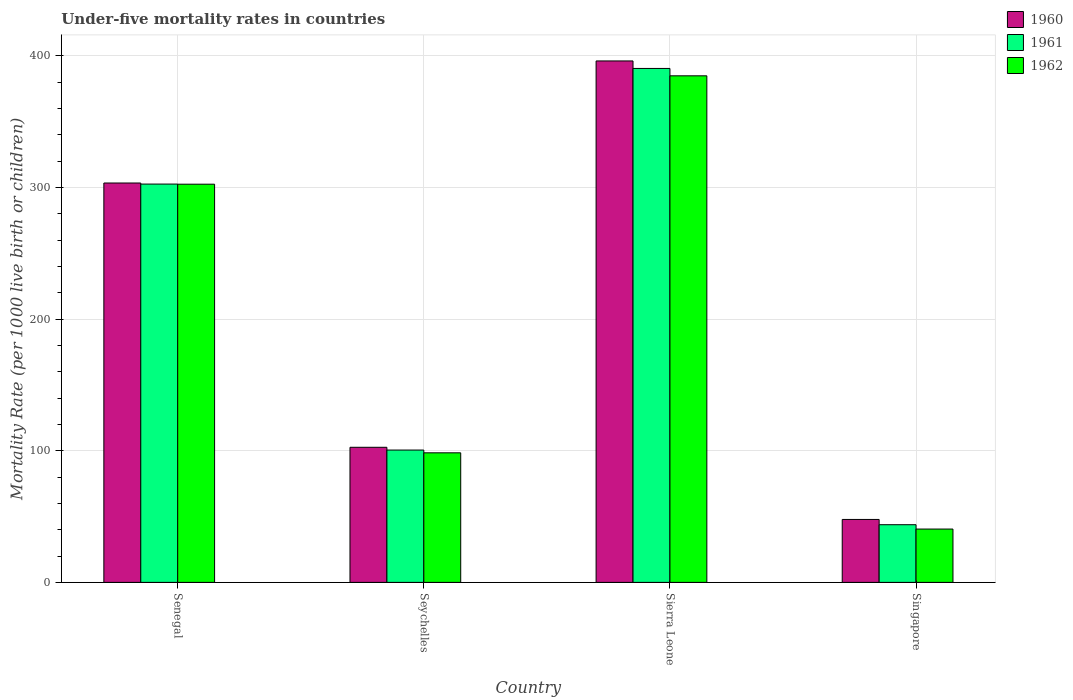How many different coloured bars are there?
Offer a very short reply. 3. How many groups of bars are there?
Provide a short and direct response. 4. Are the number of bars per tick equal to the number of legend labels?
Your answer should be very brief. Yes. Are the number of bars on each tick of the X-axis equal?
Provide a short and direct response. Yes. How many bars are there on the 4th tick from the left?
Your response must be concise. 3. What is the label of the 3rd group of bars from the left?
Keep it short and to the point. Sierra Leone. In how many cases, is the number of bars for a given country not equal to the number of legend labels?
Offer a very short reply. 0. What is the under-five mortality rate in 1960 in Sierra Leone?
Make the answer very short. 396. Across all countries, what is the maximum under-five mortality rate in 1961?
Your response must be concise. 390.3. Across all countries, what is the minimum under-five mortality rate in 1960?
Keep it short and to the point. 47.8. In which country was the under-five mortality rate in 1962 maximum?
Your answer should be compact. Sierra Leone. In which country was the under-five mortality rate in 1960 minimum?
Your response must be concise. Singapore. What is the total under-five mortality rate in 1961 in the graph?
Give a very brief answer. 837.1. What is the difference between the under-five mortality rate in 1962 in Sierra Leone and that in Singapore?
Keep it short and to the point. 344.2. What is the difference between the under-five mortality rate in 1960 in Sierra Leone and the under-five mortality rate in 1961 in Senegal?
Provide a succinct answer. 93.5. What is the average under-five mortality rate in 1961 per country?
Keep it short and to the point. 209.27. What is the difference between the under-five mortality rate of/in 1961 and under-five mortality rate of/in 1962 in Seychelles?
Provide a short and direct response. 2.1. In how many countries, is the under-five mortality rate in 1960 greater than 80?
Offer a very short reply. 3. What is the ratio of the under-five mortality rate in 1962 in Senegal to that in Singapore?
Ensure brevity in your answer.  7.47. What is the difference between the highest and the second highest under-five mortality rate in 1961?
Your answer should be compact. 202. What is the difference between the highest and the lowest under-five mortality rate in 1960?
Provide a short and direct response. 348.2. In how many countries, is the under-five mortality rate in 1960 greater than the average under-five mortality rate in 1960 taken over all countries?
Offer a very short reply. 2. What does the 1st bar from the left in Sierra Leone represents?
Offer a very short reply. 1960. How many bars are there?
Your answer should be very brief. 12. Are all the bars in the graph horizontal?
Ensure brevity in your answer.  No. How many countries are there in the graph?
Make the answer very short. 4. What is the difference between two consecutive major ticks on the Y-axis?
Keep it short and to the point. 100. Does the graph contain any zero values?
Your answer should be compact. No. Does the graph contain grids?
Make the answer very short. Yes. Where does the legend appear in the graph?
Your answer should be compact. Top right. What is the title of the graph?
Offer a very short reply. Under-five mortality rates in countries. What is the label or title of the X-axis?
Keep it short and to the point. Country. What is the label or title of the Y-axis?
Provide a short and direct response. Mortality Rate (per 1000 live birth or children). What is the Mortality Rate (per 1000 live birth or children) in 1960 in Senegal?
Make the answer very short. 303.3. What is the Mortality Rate (per 1000 live birth or children) of 1961 in Senegal?
Provide a succinct answer. 302.5. What is the Mortality Rate (per 1000 live birth or children) of 1962 in Senegal?
Your answer should be compact. 302.4. What is the Mortality Rate (per 1000 live birth or children) of 1960 in Seychelles?
Ensure brevity in your answer.  102.6. What is the Mortality Rate (per 1000 live birth or children) in 1961 in Seychelles?
Your answer should be very brief. 100.5. What is the Mortality Rate (per 1000 live birth or children) in 1962 in Seychelles?
Your answer should be compact. 98.4. What is the Mortality Rate (per 1000 live birth or children) in 1960 in Sierra Leone?
Keep it short and to the point. 396. What is the Mortality Rate (per 1000 live birth or children) in 1961 in Sierra Leone?
Make the answer very short. 390.3. What is the Mortality Rate (per 1000 live birth or children) in 1962 in Sierra Leone?
Your answer should be very brief. 384.7. What is the Mortality Rate (per 1000 live birth or children) in 1960 in Singapore?
Ensure brevity in your answer.  47.8. What is the Mortality Rate (per 1000 live birth or children) in 1961 in Singapore?
Ensure brevity in your answer.  43.8. What is the Mortality Rate (per 1000 live birth or children) in 1962 in Singapore?
Your answer should be very brief. 40.5. Across all countries, what is the maximum Mortality Rate (per 1000 live birth or children) in 1960?
Offer a terse response. 396. Across all countries, what is the maximum Mortality Rate (per 1000 live birth or children) in 1961?
Your answer should be compact. 390.3. Across all countries, what is the maximum Mortality Rate (per 1000 live birth or children) in 1962?
Your answer should be compact. 384.7. Across all countries, what is the minimum Mortality Rate (per 1000 live birth or children) of 1960?
Provide a succinct answer. 47.8. Across all countries, what is the minimum Mortality Rate (per 1000 live birth or children) in 1961?
Provide a short and direct response. 43.8. Across all countries, what is the minimum Mortality Rate (per 1000 live birth or children) of 1962?
Give a very brief answer. 40.5. What is the total Mortality Rate (per 1000 live birth or children) of 1960 in the graph?
Give a very brief answer. 849.7. What is the total Mortality Rate (per 1000 live birth or children) of 1961 in the graph?
Provide a short and direct response. 837.1. What is the total Mortality Rate (per 1000 live birth or children) of 1962 in the graph?
Give a very brief answer. 826. What is the difference between the Mortality Rate (per 1000 live birth or children) of 1960 in Senegal and that in Seychelles?
Your response must be concise. 200.7. What is the difference between the Mortality Rate (per 1000 live birth or children) in 1961 in Senegal and that in Seychelles?
Keep it short and to the point. 202. What is the difference between the Mortality Rate (per 1000 live birth or children) of 1962 in Senegal and that in Seychelles?
Offer a terse response. 204. What is the difference between the Mortality Rate (per 1000 live birth or children) in 1960 in Senegal and that in Sierra Leone?
Provide a succinct answer. -92.7. What is the difference between the Mortality Rate (per 1000 live birth or children) in 1961 in Senegal and that in Sierra Leone?
Offer a very short reply. -87.8. What is the difference between the Mortality Rate (per 1000 live birth or children) in 1962 in Senegal and that in Sierra Leone?
Your answer should be very brief. -82.3. What is the difference between the Mortality Rate (per 1000 live birth or children) of 1960 in Senegal and that in Singapore?
Provide a short and direct response. 255.5. What is the difference between the Mortality Rate (per 1000 live birth or children) of 1961 in Senegal and that in Singapore?
Keep it short and to the point. 258.7. What is the difference between the Mortality Rate (per 1000 live birth or children) of 1962 in Senegal and that in Singapore?
Your response must be concise. 261.9. What is the difference between the Mortality Rate (per 1000 live birth or children) in 1960 in Seychelles and that in Sierra Leone?
Provide a short and direct response. -293.4. What is the difference between the Mortality Rate (per 1000 live birth or children) in 1961 in Seychelles and that in Sierra Leone?
Your answer should be very brief. -289.8. What is the difference between the Mortality Rate (per 1000 live birth or children) of 1962 in Seychelles and that in Sierra Leone?
Ensure brevity in your answer.  -286.3. What is the difference between the Mortality Rate (per 1000 live birth or children) of 1960 in Seychelles and that in Singapore?
Provide a short and direct response. 54.8. What is the difference between the Mortality Rate (per 1000 live birth or children) in 1961 in Seychelles and that in Singapore?
Provide a succinct answer. 56.7. What is the difference between the Mortality Rate (per 1000 live birth or children) in 1962 in Seychelles and that in Singapore?
Keep it short and to the point. 57.9. What is the difference between the Mortality Rate (per 1000 live birth or children) in 1960 in Sierra Leone and that in Singapore?
Your answer should be very brief. 348.2. What is the difference between the Mortality Rate (per 1000 live birth or children) of 1961 in Sierra Leone and that in Singapore?
Give a very brief answer. 346.5. What is the difference between the Mortality Rate (per 1000 live birth or children) of 1962 in Sierra Leone and that in Singapore?
Give a very brief answer. 344.2. What is the difference between the Mortality Rate (per 1000 live birth or children) of 1960 in Senegal and the Mortality Rate (per 1000 live birth or children) of 1961 in Seychelles?
Your answer should be very brief. 202.8. What is the difference between the Mortality Rate (per 1000 live birth or children) of 1960 in Senegal and the Mortality Rate (per 1000 live birth or children) of 1962 in Seychelles?
Ensure brevity in your answer.  204.9. What is the difference between the Mortality Rate (per 1000 live birth or children) in 1961 in Senegal and the Mortality Rate (per 1000 live birth or children) in 1962 in Seychelles?
Offer a terse response. 204.1. What is the difference between the Mortality Rate (per 1000 live birth or children) in 1960 in Senegal and the Mortality Rate (per 1000 live birth or children) in 1961 in Sierra Leone?
Provide a succinct answer. -87. What is the difference between the Mortality Rate (per 1000 live birth or children) of 1960 in Senegal and the Mortality Rate (per 1000 live birth or children) of 1962 in Sierra Leone?
Your answer should be compact. -81.4. What is the difference between the Mortality Rate (per 1000 live birth or children) of 1961 in Senegal and the Mortality Rate (per 1000 live birth or children) of 1962 in Sierra Leone?
Your response must be concise. -82.2. What is the difference between the Mortality Rate (per 1000 live birth or children) of 1960 in Senegal and the Mortality Rate (per 1000 live birth or children) of 1961 in Singapore?
Keep it short and to the point. 259.5. What is the difference between the Mortality Rate (per 1000 live birth or children) of 1960 in Senegal and the Mortality Rate (per 1000 live birth or children) of 1962 in Singapore?
Offer a terse response. 262.8. What is the difference between the Mortality Rate (per 1000 live birth or children) in 1961 in Senegal and the Mortality Rate (per 1000 live birth or children) in 1962 in Singapore?
Provide a short and direct response. 262. What is the difference between the Mortality Rate (per 1000 live birth or children) in 1960 in Seychelles and the Mortality Rate (per 1000 live birth or children) in 1961 in Sierra Leone?
Offer a terse response. -287.7. What is the difference between the Mortality Rate (per 1000 live birth or children) in 1960 in Seychelles and the Mortality Rate (per 1000 live birth or children) in 1962 in Sierra Leone?
Give a very brief answer. -282.1. What is the difference between the Mortality Rate (per 1000 live birth or children) in 1961 in Seychelles and the Mortality Rate (per 1000 live birth or children) in 1962 in Sierra Leone?
Provide a short and direct response. -284.2. What is the difference between the Mortality Rate (per 1000 live birth or children) in 1960 in Seychelles and the Mortality Rate (per 1000 live birth or children) in 1961 in Singapore?
Your response must be concise. 58.8. What is the difference between the Mortality Rate (per 1000 live birth or children) in 1960 in Seychelles and the Mortality Rate (per 1000 live birth or children) in 1962 in Singapore?
Give a very brief answer. 62.1. What is the difference between the Mortality Rate (per 1000 live birth or children) in 1960 in Sierra Leone and the Mortality Rate (per 1000 live birth or children) in 1961 in Singapore?
Your answer should be very brief. 352.2. What is the difference between the Mortality Rate (per 1000 live birth or children) of 1960 in Sierra Leone and the Mortality Rate (per 1000 live birth or children) of 1962 in Singapore?
Make the answer very short. 355.5. What is the difference between the Mortality Rate (per 1000 live birth or children) of 1961 in Sierra Leone and the Mortality Rate (per 1000 live birth or children) of 1962 in Singapore?
Keep it short and to the point. 349.8. What is the average Mortality Rate (per 1000 live birth or children) in 1960 per country?
Offer a very short reply. 212.43. What is the average Mortality Rate (per 1000 live birth or children) in 1961 per country?
Your answer should be very brief. 209.28. What is the average Mortality Rate (per 1000 live birth or children) in 1962 per country?
Your answer should be compact. 206.5. What is the difference between the Mortality Rate (per 1000 live birth or children) of 1960 and Mortality Rate (per 1000 live birth or children) of 1961 in Senegal?
Keep it short and to the point. 0.8. What is the difference between the Mortality Rate (per 1000 live birth or children) of 1960 and Mortality Rate (per 1000 live birth or children) of 1961 in Seychelles?
Offer a terse response. 2.1. What is the difference between the Mortality Rate (per 1000 live birth or children) in 1960 and Mortality Rate (per 1000 live birth or children) in 1962 in Seychelles?
Make the answer very short. 4.2. What is the difference between the Mortality Rate (per 1000 live birth or children) of 1961 and Mortality Rate (per 1000 live birth or children) of 1962 in Seychelles?
Your response must be concise. 2.1. What is the difference between the Mortality Rate (per 1000 live birth or children) in 1960 and Mortality Rate (per 1000 live birth or children) in 1961 in Sierra Leone?
Your answer should be very brief. 5.7. What is the difference between the Mortality Rate (per 1000 live birth or children) in 1960 and Mortality Rate (per 1000 live birth or children) in 1962 in Sierra Leone?
Offer a very short reply. 11.3. What is the difference between the Mortality Rate (per 1000 live birth or children) in 1960 and Mortality Rate (per 1000 live birth or children) in 1961 in Singapore?
Provide a succinct answer. 4. What is the difference between the Mortality Rate (per 1000 live birth or children) in 1960 and Mortality Rate (per 1000 live birth or children) in 1962 in Singapore?
Provide a short and direct response. 7.3. What is the difference between the Mortality Rate (per 1000 live birth or children) of 1961 and Mortality Rate (per 1000 live birth or children) of 1962 in Singapore?
Your response must be concise. 3.3. What is the ratio of the Mortality Rate (per 1000 live birth or children) in 1960 in Senegal to that in Seychelles?
Ensure brevity in your answer.  2.96. What is the ratio of the Mortality Rate (per 1000 live birth or children) in 1961 in Senegal to that in Seychelles?
Offer a very short reply. 3.01. What is the ratio of the Mortality Rate (per 1000 live birth or children) of 1962 in Senegal to that in Seychelles?
Make the answer very short. 3.07. What is the ratio of the Mortality Rate (per 1000 live birth or children) of 1960 in Senegal to that in Sierra Leone?
Provide a short and direct response. 0.77. What is the ratio of the Mortality Rate (per 1000 live birth or children) in 1961 in Senegal to that in Sierra Leone?
Keep it short and to the point. 0.78. What is the ratio of the Mortality Rate (per 1000 live birth or children) in 1962 in Senegal to that in Sierra Leone?
Offer a terse response. 0.79. What is the ratio of the Mortality Rate (per 1000 live birth or children) in 1960 in Senegal to that in Singapore?
Make the answer very short. 6.35. What is the ratio of the Mortality Rate (per 1000 live birth or children) of 1961 in Senegal to that in Singapore?
Your response must be concise. 6.91. What is the ratio of the Mortality Rate (per 1000 live birth or children) in 1962 in Senegal to that in Singapore?
Your answer should be compact. 7.47. What is the ratio of the Mortality Rate (per 1000 live birth or children) of 1960 in Seychelles to that in Sierra Leone?
Your answer should be compact. 0.26. What is the ratio of the Mortality Rate (per 1000 live birth or children) of 1961 in Seychelles to that in Sierra Leone?
Give a very brief answer. 0.26. What is the ratio of the Mortality Rate (per 1000 live birth or children) in 1962 in Seychelles to that in Sierra Leone?
Offer a very short reply. 0.26. What is the ratio of the Mortality Rate (per 1000 live birth or children) of 1960 in Seychelles to that in Singapore?
Offer a very short reply. 2.15. What is the ratio of the Mortality Rate (per 1000 live birth or children) of 1961 in Seychelles to that in Singapore?
Ensure brevity in your answer.  2.29. What is the ratio of the Mortality Rate (per 1000 live birth or children) of 1962 in Seychelles to that in Singapore?
Offer a terse response. 2.43. What is the ratio of the Mortality Rate (per 1000 live birth or children) of 1960 in Sierra Leone to that in Singapore?
Ensure brevity in your answer.  8.28. What is the ratio of the Mortality Rate (per 1000 live birth or children) of 1961 in Sierra Leone to that in Singapore?
Provide a succinct answer. 8.91. What is the ratio of the Mortality Rate (per 1000 live birth or children) in 1962 in Sierra Leone to that in Singapore?
Your answer should be compact. 9.5. What is the difference between the highest and the second highest Mortality Rate (per 1000 live birth or children) in 1960?
Provide a short and direct response. 92.7. What is the difference between the highest and the second highest Mortality Rate (per 1000 live birth or children) of 1961?
Your answer should be compact. 87.8. What is the difference between the highest and the second highest Mortality Rate (per 1000 live birth or children) of 1962?
Offer a terse response. 82.3. What is the difference between the highest and the lowest Mortality Rate (per 1000 live birth or children) in 1960?
Your answer should be compact. 348.2. What is the difference between the highest and the lowest Mortality Rate (per 1000 live birth or children) in 1961?
Offer a terse response. 346.5. What is the difference between the highest and the lowest Mortality Rate (per 1000 live birth or children) of 1962?
Offer a very short reply. 344.2. 